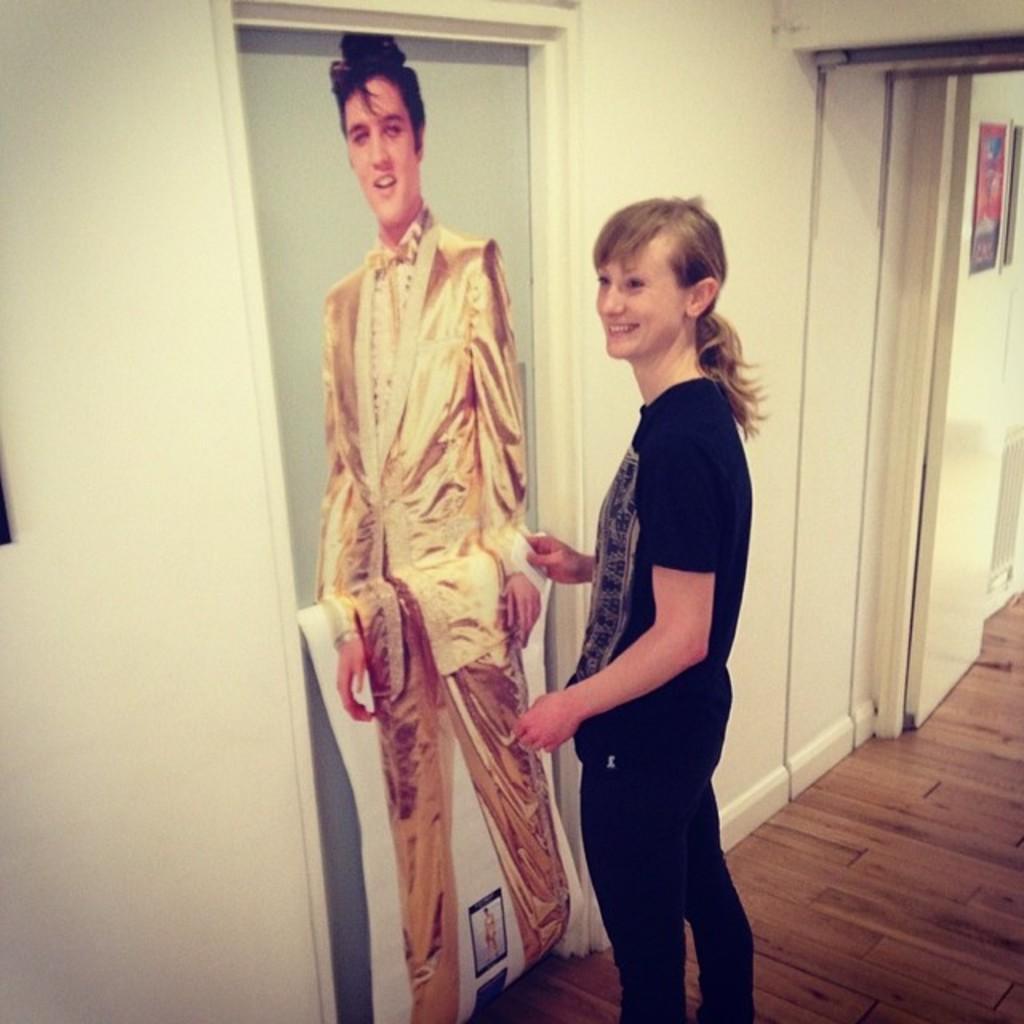In one or two sentences, can you explain what this image depicts? In this picture we can see a person on the floor, in front of this person we can see a photo of a poster on the door and we can see a wall. 